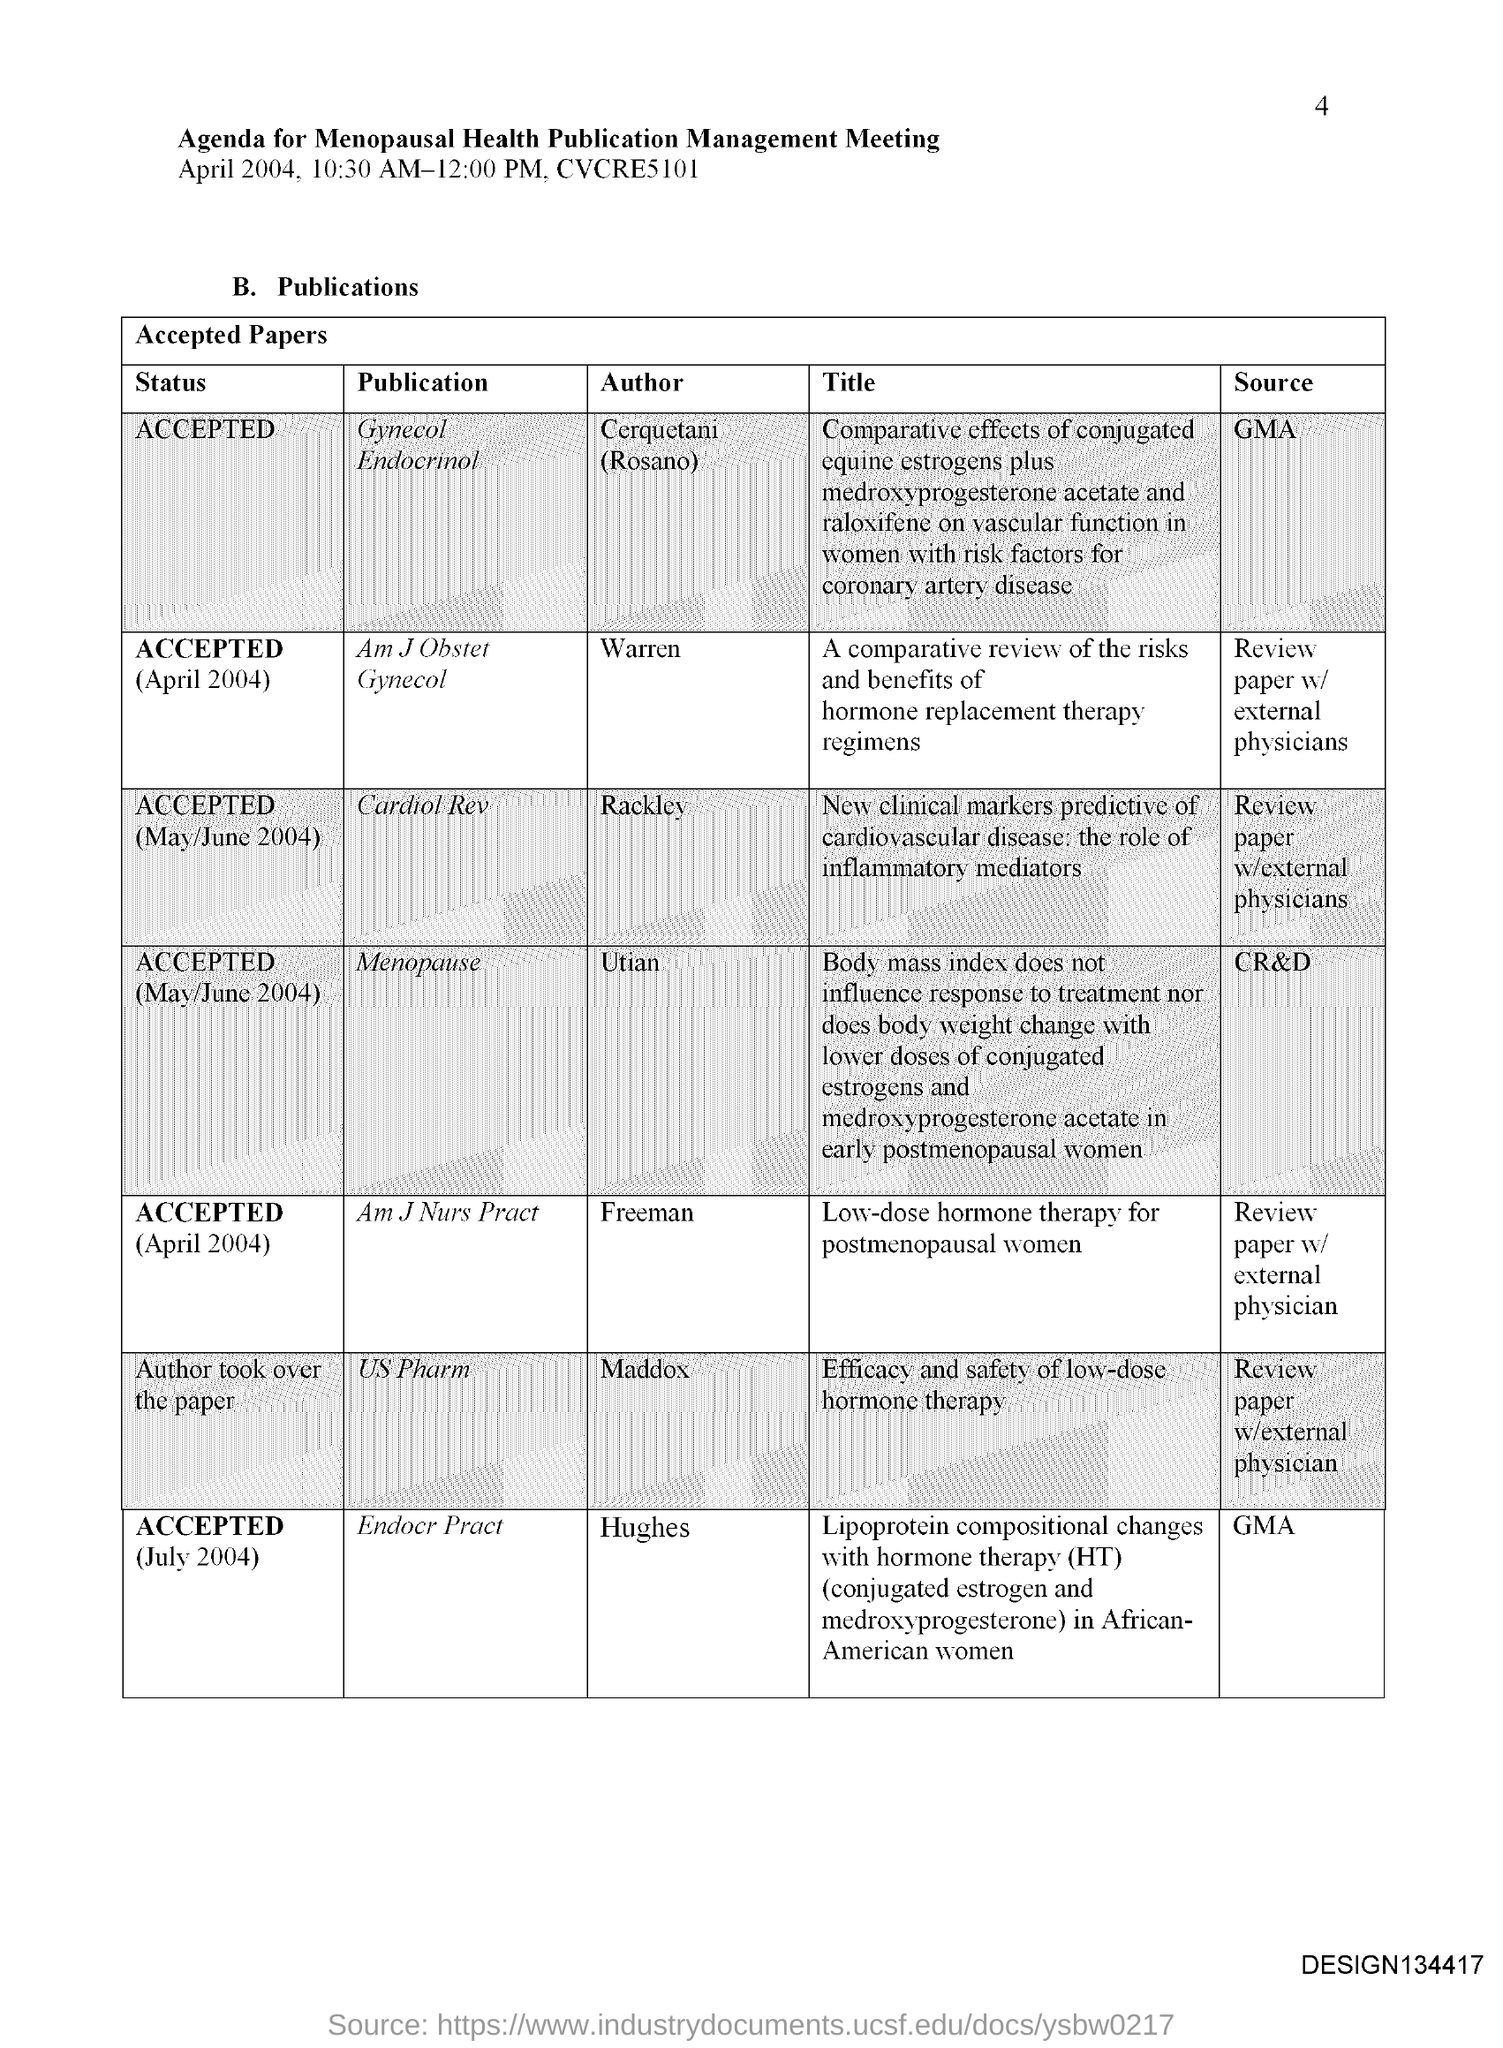Who is the author of the publication Menopause?
Keep it short and to the point. Utian. Rackley is the author of which publication?
Offer a very short reply. Cardiol Rev. Hughes is the author of which publication?
Offer a very short reply. Endocr Pract. 